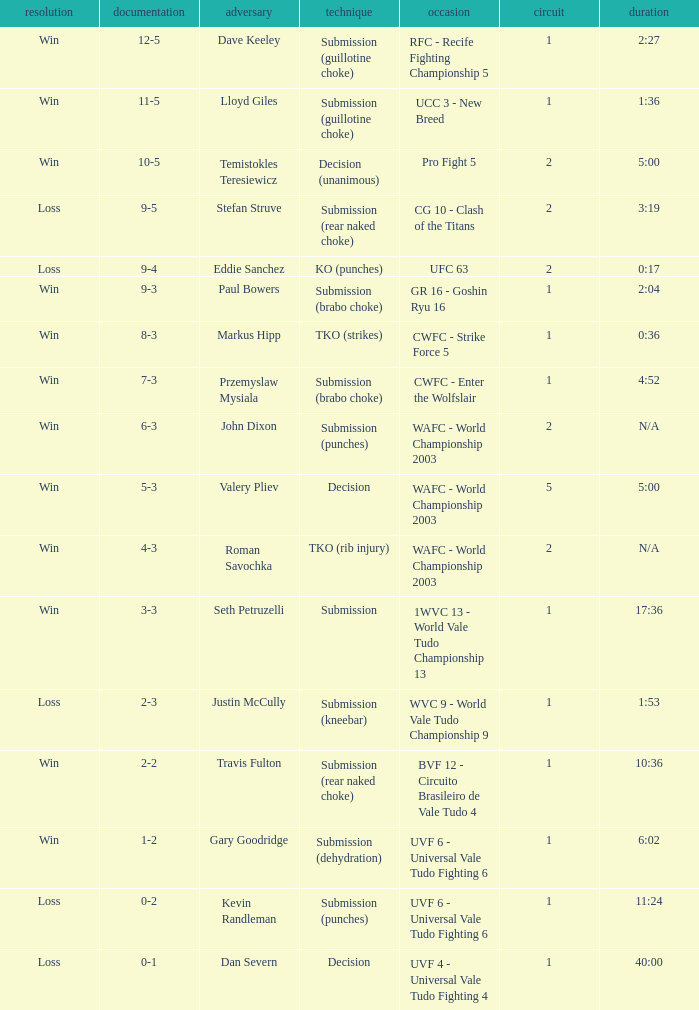What opponent uses the method of decision and a 5-3 record? Valery Pliev. 